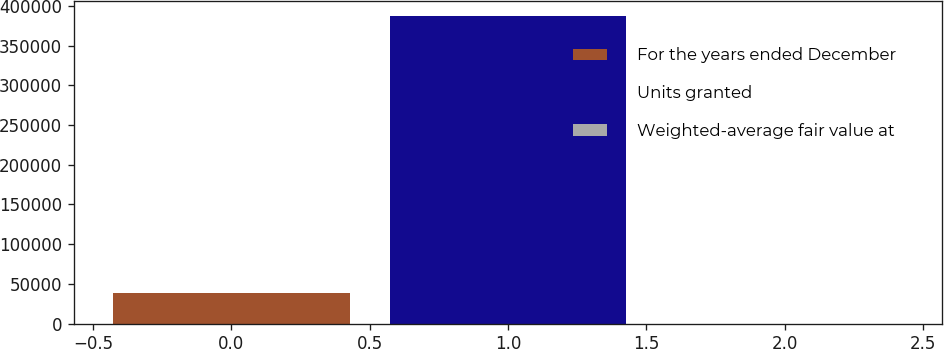Convert chart to OTSL. <chart><loc_0><loc_0><loc_500><loc_500><bar_chart><fcel>For the years ended December<fcel>Units granted<fcel>Weighted-average fair value at<nl><fcel>38759.2<fcel>387143<fcel>49.83<nl></chart> 